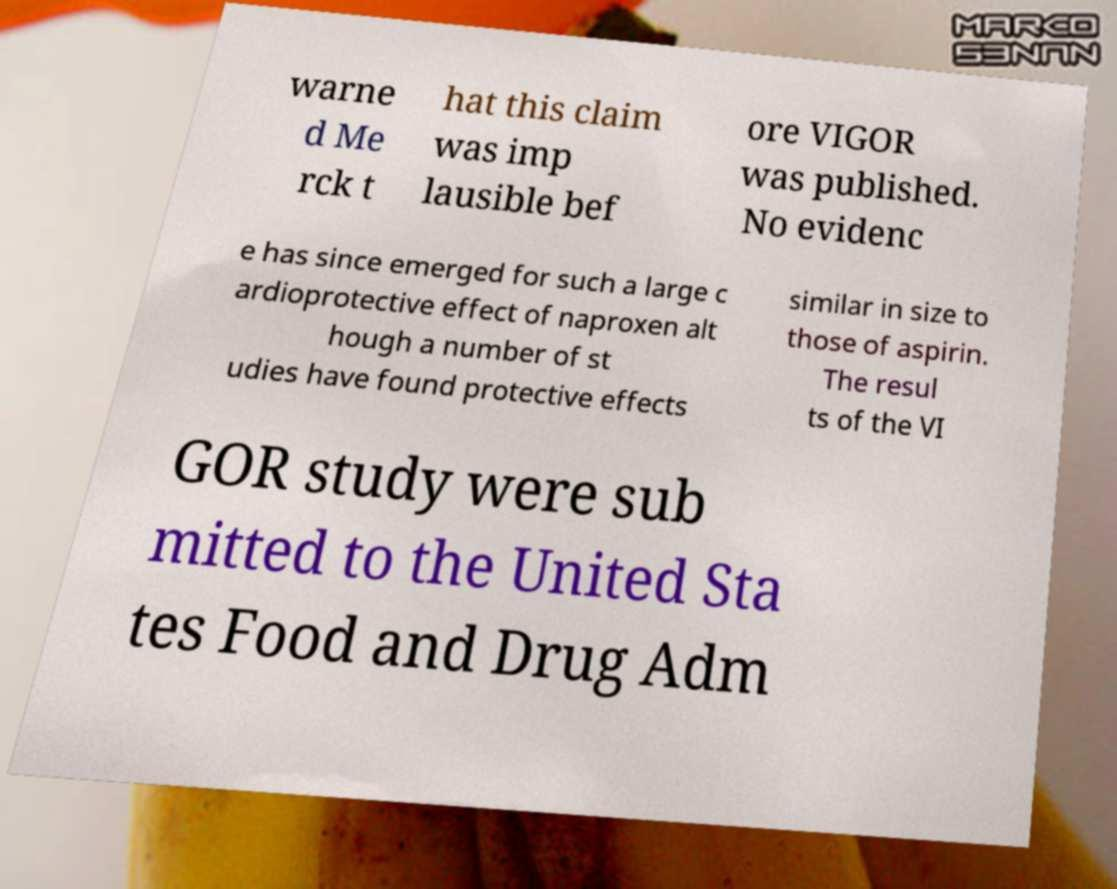For documentation purposes, I need the text within this image transcribed. Could you provide that? warne d Me rck t hat this claim was imp lausible bef ore VIGOR was published. No evidenc e has since emerged for such a large c ardioprotective effect of naproxen alt hough a number of st udies have found protective effects similar in size to those of aspirin. The resul ts of the VI GOR study were sub mitted to the United Sta tes Food and Drug Adm 